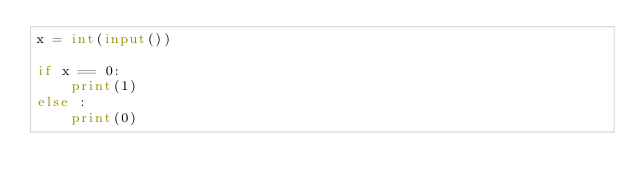<code> <loc_0><loc_0><loc_500><loc_500><_Python_>x = int(input())

if x == 0:
    print(1)
else :
    print(0)
</code> 